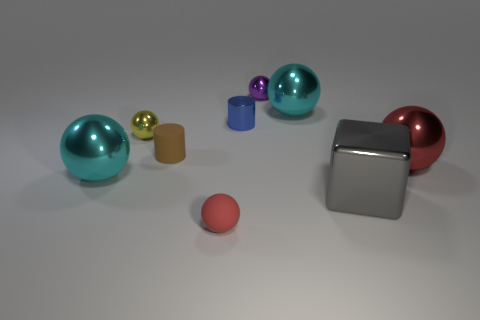Subtract all red balls. How many were subtracted if there are1red balls left? 1 Subtract 2 red balls. How many objects are left? 7 Subtract all cylinders. How many objects are left? 7 Subtract 3 spheres. How many spheres are left? 3 Subtract all cyan spheres. Subtract all green cylinders. How many spheres are left? 4 Subtract all green cubes. How many blue cylinders are left? 1 Subtract all small matte spheres. Subtract all brown rubber objects. How many objects are left? 7 Add 4 red things. How many red things are left? 6 Add 8 tiny blue shiny cylinders. How many tiny blue shiny cylinders exist? 9 Add 1 blue rubber balls. How many objects exist? 10 